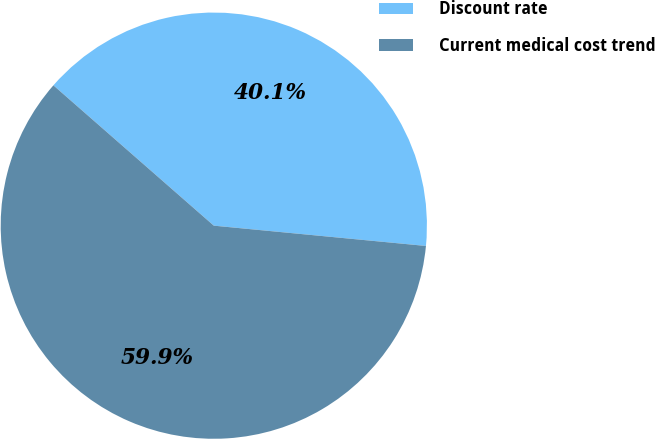<chart> <loc_0><loc_0><loc_500><loc_500><pie_chart><fcel>Discount rate<fcel>Current medical cost trend<nl><fcel>40.08%<fcel>59.92%<nl></chart> 